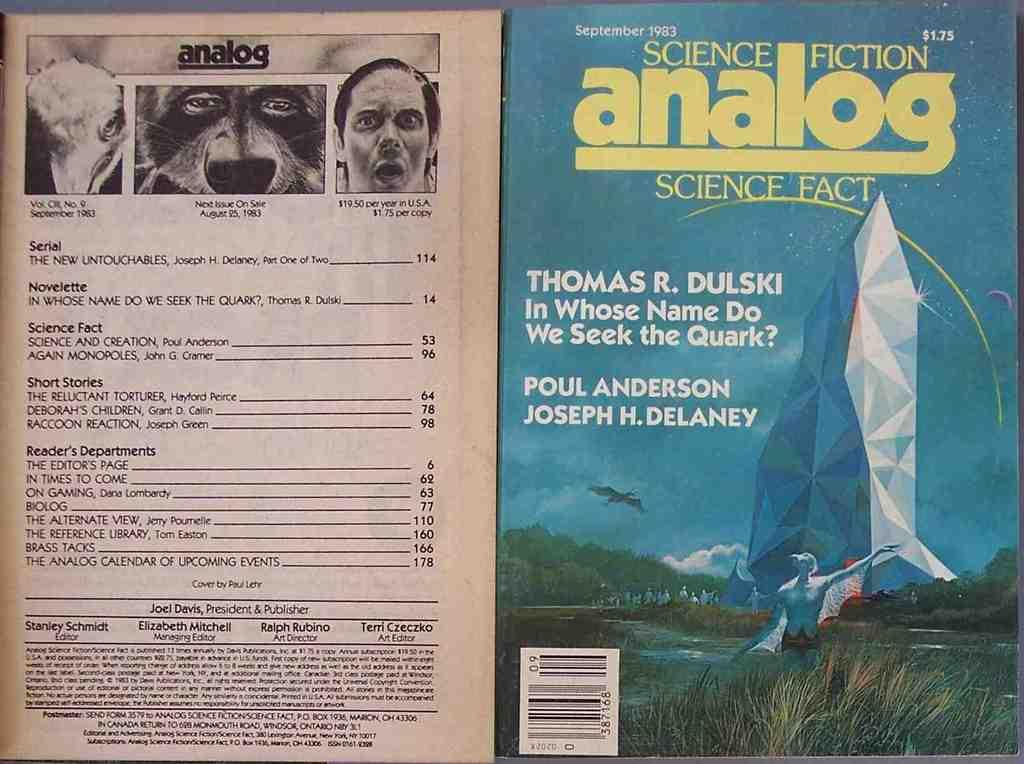What type of medium is the image part of? The image is the cover page of a book. How many ants can be seen crawling on the book cover in the image? There are no ants present on the book cover in the image. 